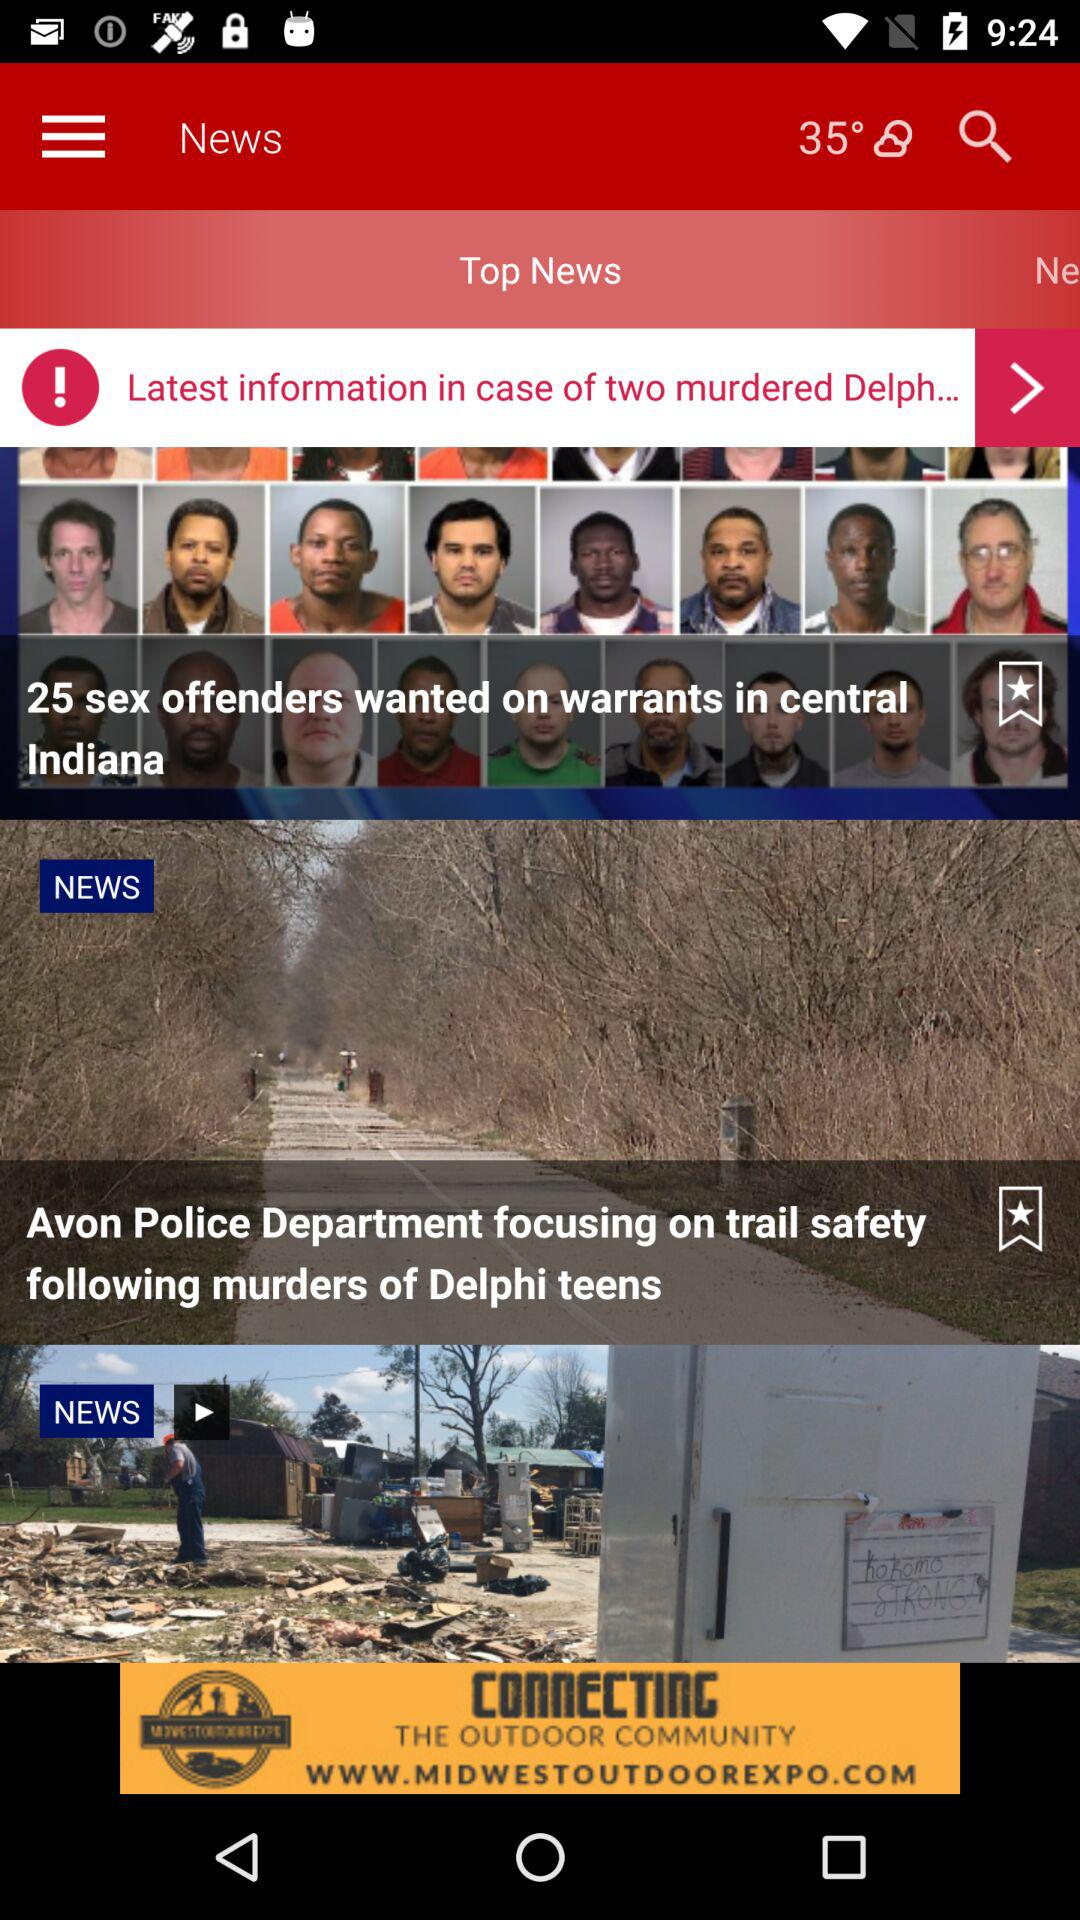What is the weather forecast? The weather is partly cloudy. 